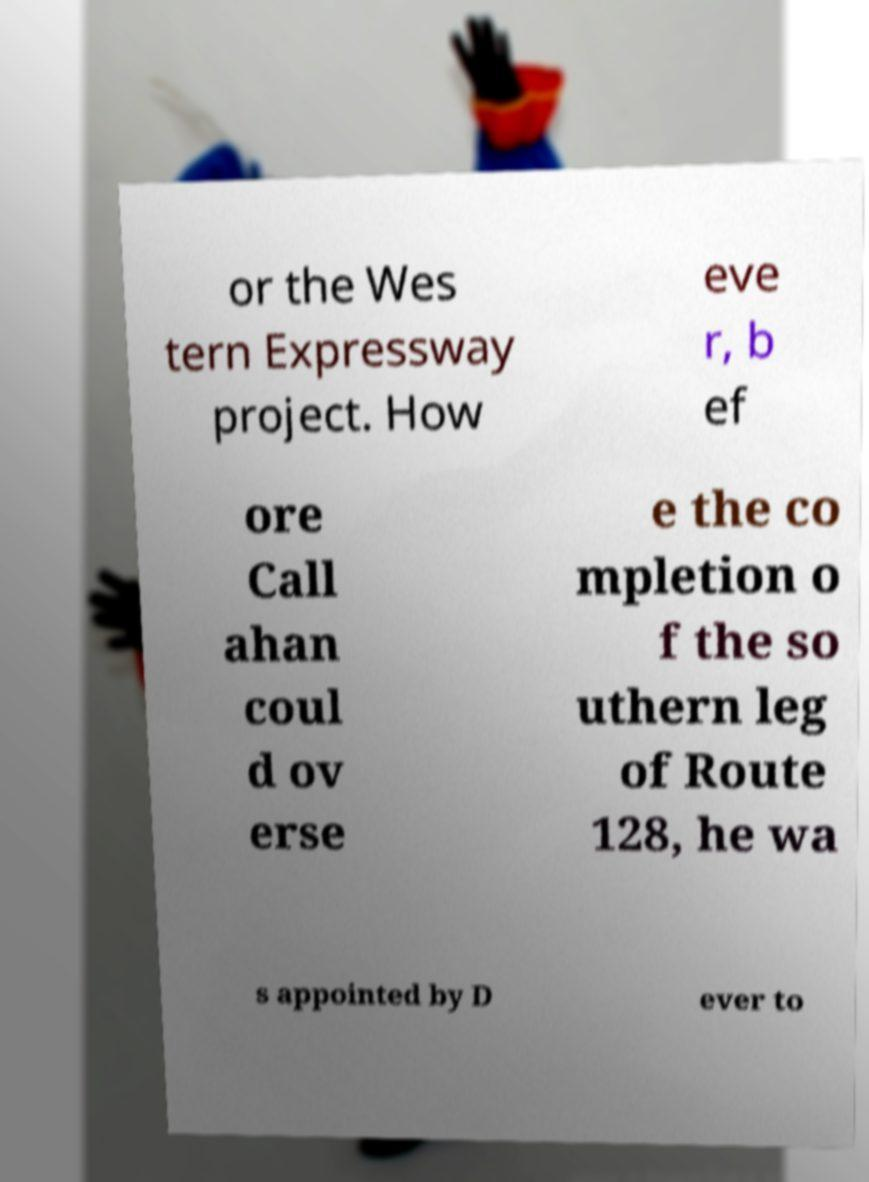There's text embedded in this image that I need extracted. Can you transcribe it verbatim? or the Wes tern Expressway project. How eve r, b ef ore Call ahan coul d ov erse e the co mpletion o f the so uthern leg of Route 128, he wa s appointed by D ever to 